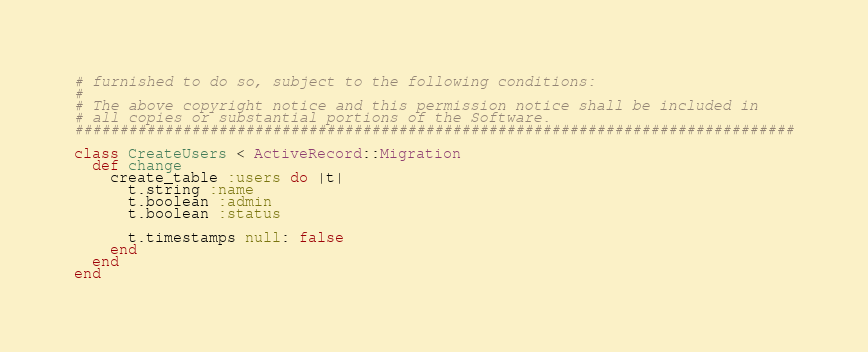<code> <loc_0><loc_0><loc_500><loc_500><_Ruby_># furnished to do so, subject to the following conditions:
#
# The above copyright notice and this permission notice shall be included in
# all copies or substantial portions of the Software.
################################################################################

class CreateUsers < ActiveRecord::Migration
  def change
    create_table :users do |t|
      t.string :name
      t.boolean :admin
      t.boolean :status

      t.timestamps null: false
    end
  end
end
</code> 